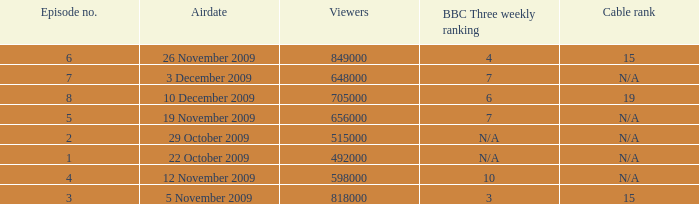How many entries are shown for viewers when the airdate was 26 november 2009? 1.0. 